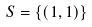<formula> <loc_0><loc_0><loc_500><loc_500>S = \{ ( 1 , 1 ) \}</formula> 